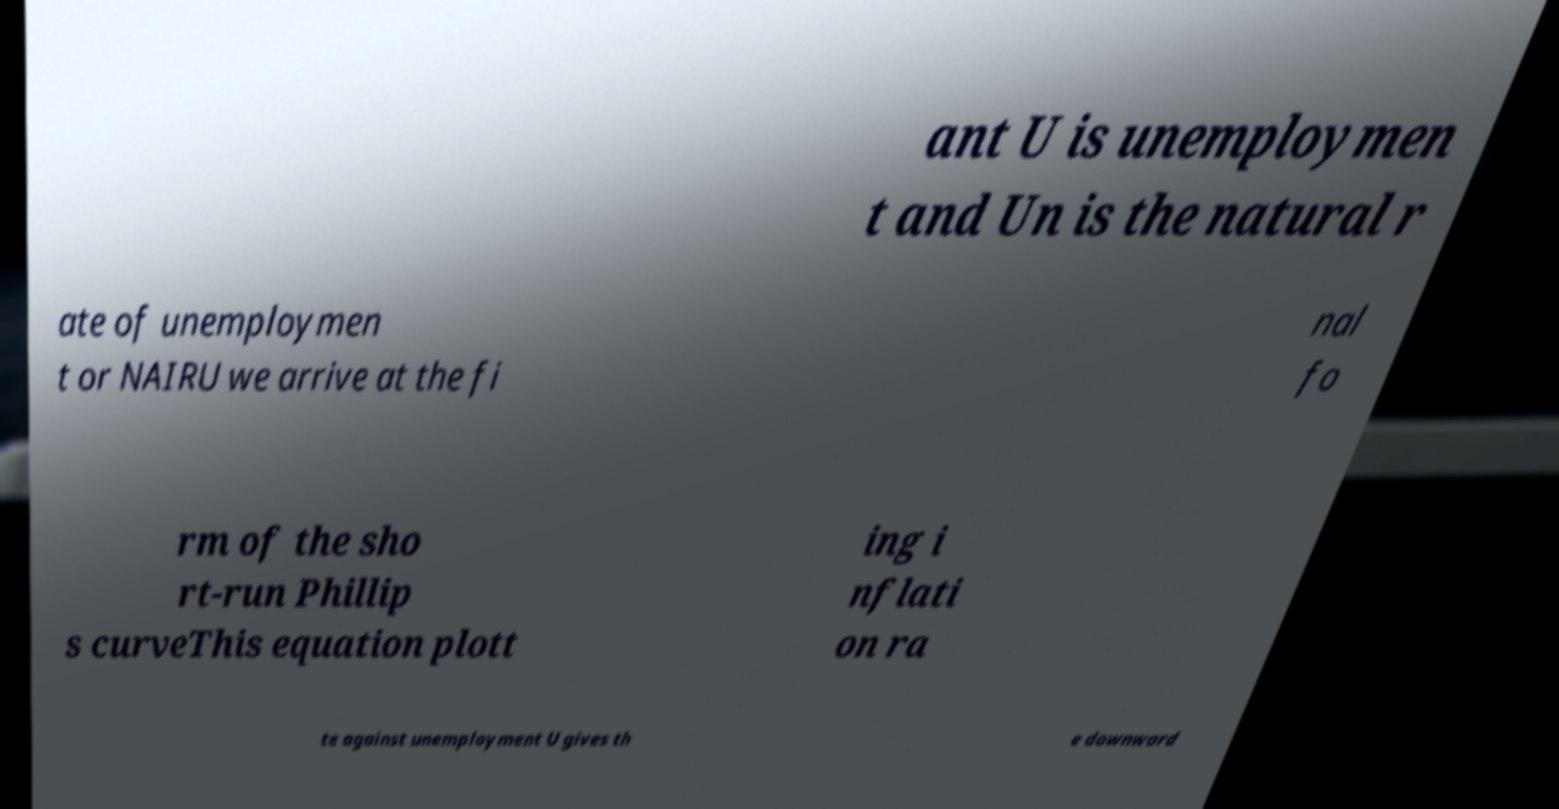Please read and relay the text visible in this image. What does it say? ant U is unemploymen t and Un is the natural r ate of unemploymen t or NAIRU we arrive at the fi nal fo rm of the sho rt-run Phillip s curveThis equation plott ing i nflati on ra te against unemployment U gives th e downward 